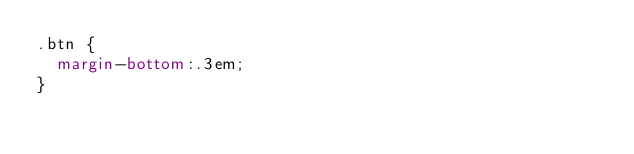<code> <loc_0><loc_0><loc_500><loc_500><_CSS_>.btn {
  margin-bottom:.3em;
}</code> 